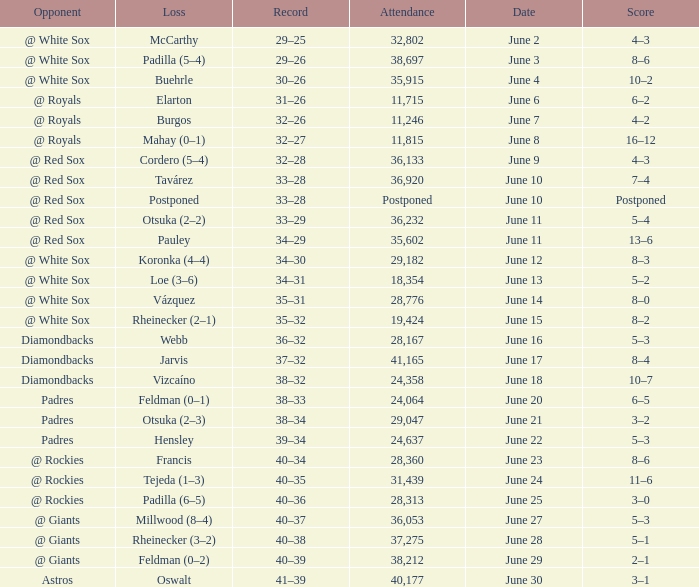When did tavárez lose? June 10. 